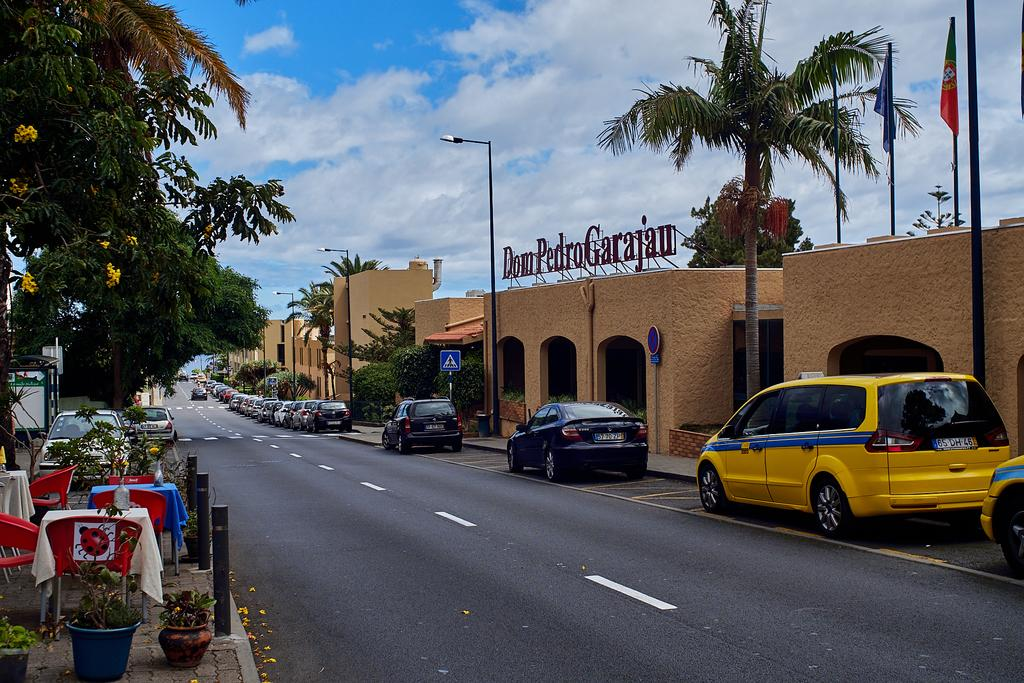<image>
Provide a brief description of the given image. Cars parked in front of a building that says Dom Pedro Garajau. 